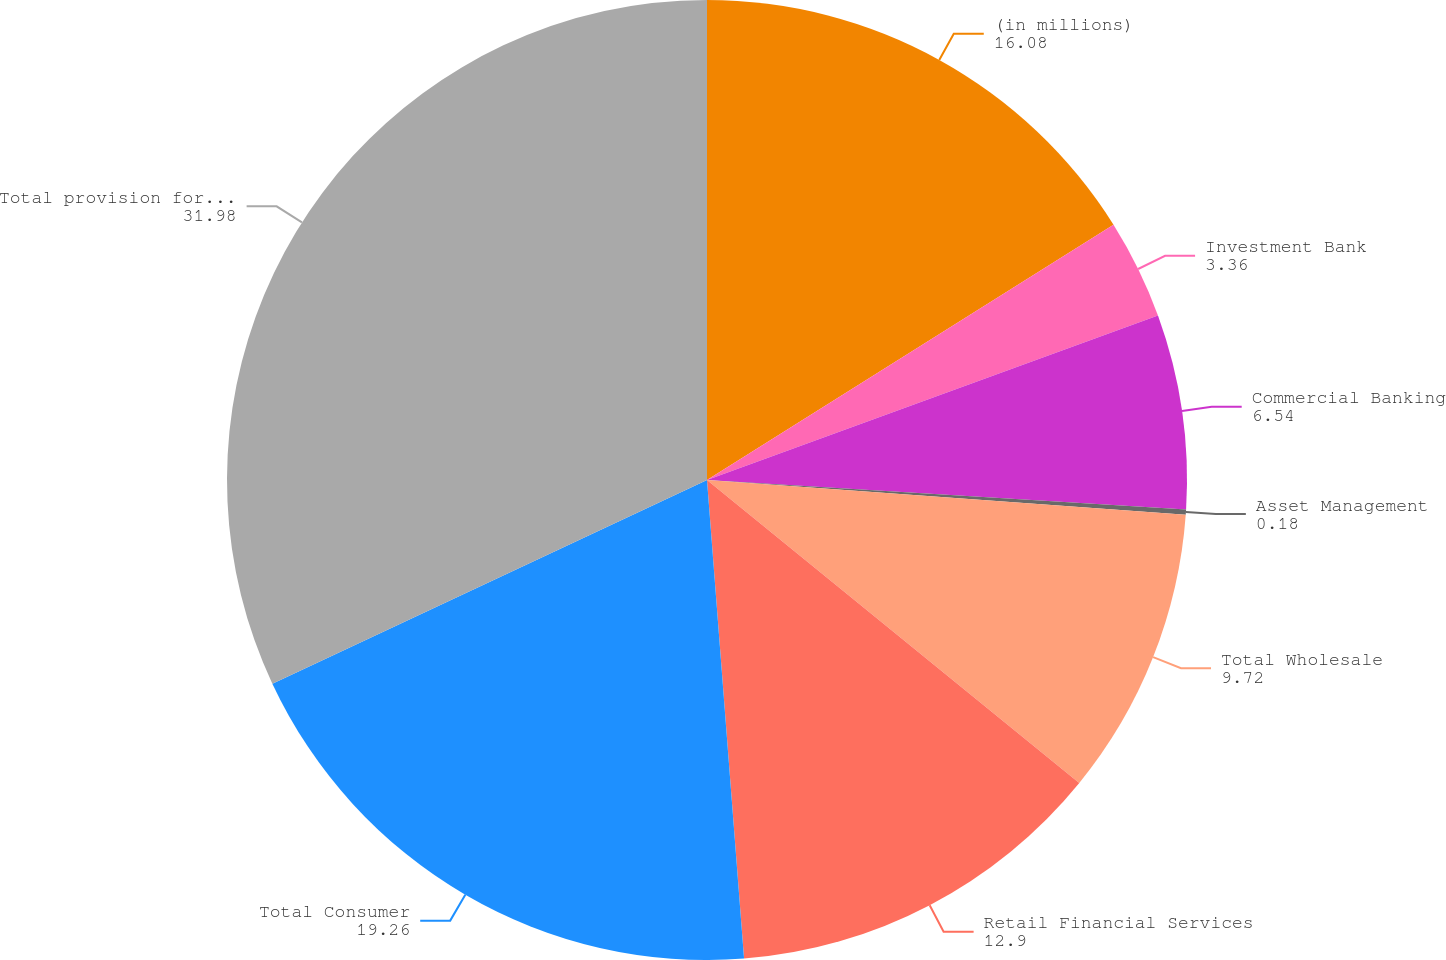<chart> <loc_0><loc_0><loc_500><loc_500><pie_chart><fcel>(in millions)<fcel>Investment Bank<fcel>Commercial Banking<fcel>Asset Management<fcel>Total Wholesale<fcel>Retail Financial Services<fcel>Total Consumer<fcel>Total provision for credit<nl><fcel>16.08%<fcel>3.36%<fcel>6.54%<fcel>0.18%<fcel>9.72%<fcel>12.9%<fcel>19.26%<fcel>31.98%<nl></chart> 